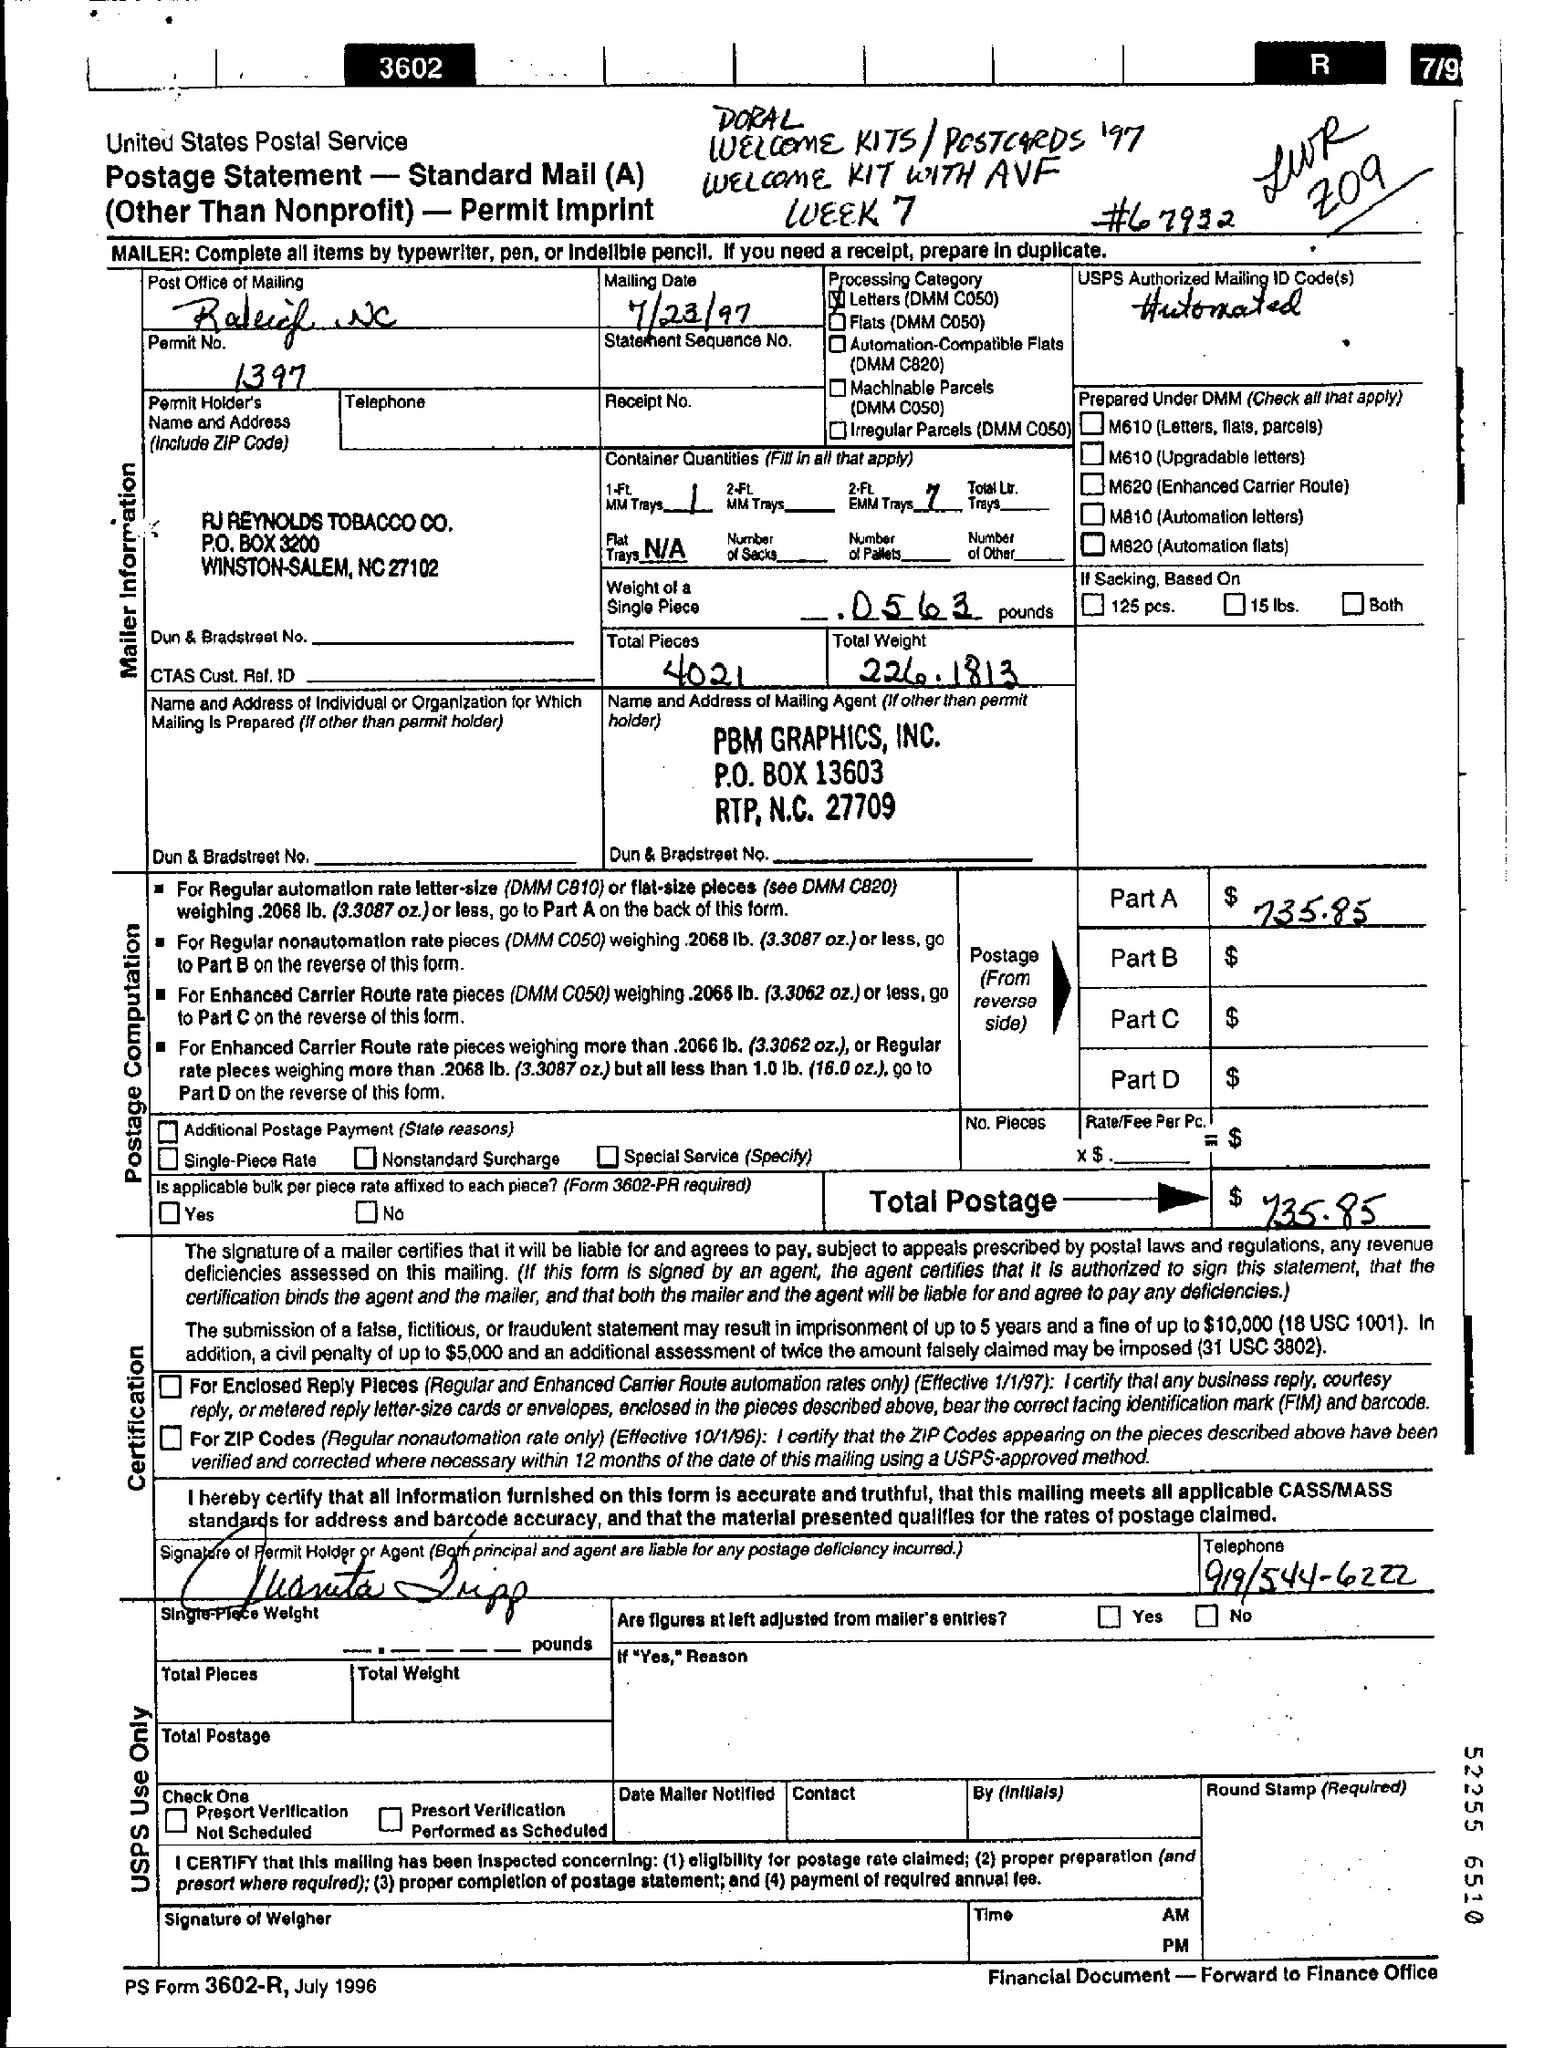Specify some key components in this picture. The total postage is $735.85. The mailing date is July 23, 1997. The weight of a single piece is approximately 0.0563 pounds. The Permit No. is 1397... The total number of pieces is 4021. 